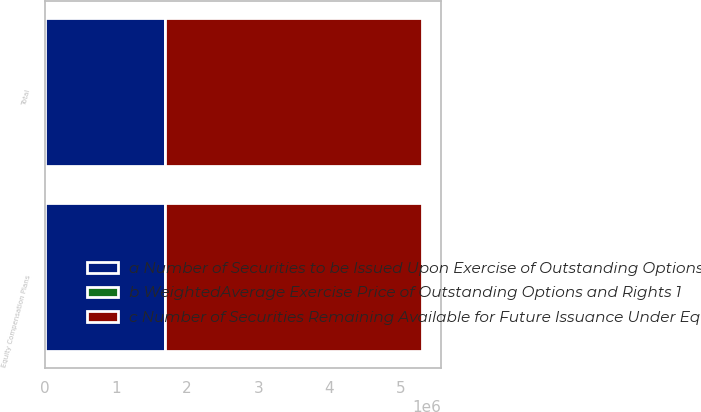Convert chart. <chart><loc_0><loc_0><loc_500><loc_500><stacked_bar_chart><ecel><fcel>Equity Compensation Plans<fcel>Total<nl><fcel>a Number of Securities to be Issued Upon Exercise of Outstanding Options and Rights 1<fcel>1.69332e+06<fcel>1.69332e+06<nl><fcel>b WeightedAverage Exercise Price of Outstanding Options and Rights 1<fcel>157.07<fcel>157.07<nl><fcel>c Number of Securities Remaining Available for Future Issuance Under Equity Compensation Plans excluding securities reflected in column a 2<fcel>3.607e+06<fcel>3.607e+06<nl></chart> 